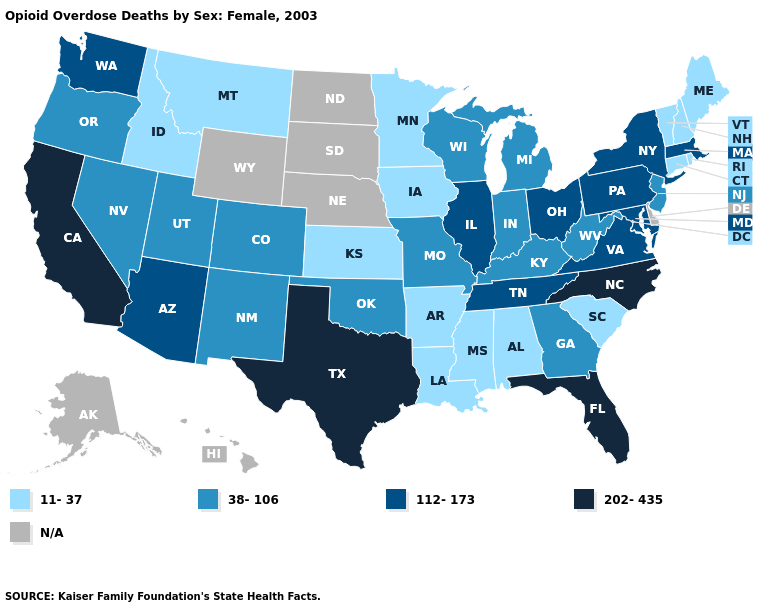Name the states that have a value in the range N/A?
Answer briefly. Alaska, Delaware, Hawaii, Nebraska, North Dakota, South Dakota, Wyoming. Which states have the lowest value in the USA?
Answer briefly. Alabama, Arkansas, Connecticut, Idaho, Iowa, Kansas, Louisiana, Maine, Minnesota, Mississippi, Montana, New Hampshire, Rhode Island, South Carolina, Vermont. What is the highest value in the Northeast ?
Short answer required. 112-173. What is the value of Arkansas?
Answer briefly. 11-37. Does Oregon have the highest value in the West?
Short answer required. No. Does Colorado have the lowest value in the West?
Be succinct. No. Does Montana have the lowest value in the West?
Be succinct. Yes. What is the lowest value in states that border Maine?
Give a very brief answer. 11-37. Name the states that have a value in the range 11-37?
Concise answer only. Alabama, Arkansas, Connecticut, Idaho, Iowa, Kansas, Louisiana, Maine, Minnesota, Mississippi, Montana, New Hampshire, Rhode Island, South Carolina, Vermont. Does the map have missing data?
Keep it brief. Yes. What is the value of Maine?
Concise answer only. 11-37. Among the states that border Kansas , which have the highest value?
Answer briefly. Colorado, Missouri, Oklahoma. What is the value of Virginia?
Keep it brief. 112-173. 